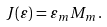<formula> <loc_0><loc_0><loc_500><loc_500>J ( \varepsilon ) = \varepsilon _ { m } M _ { m } \, .</formula> 